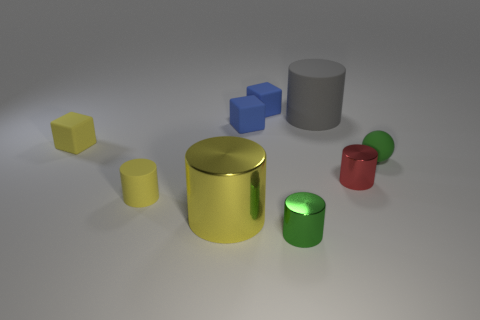Subtract all tiny yellow blocks. How many blocks are left? 2 Subtract all gray cylinders. How many blue cubes are left? 2 Add 1 tiny gray matte objects. How many objects exist? 10 Subtract all gray cylinders. How many cylinders are left? 4 Subtract 3 cylinders. How many cylinders are left? 2 Add 3 blue rubber cubes. How many blue rubber cubes are left? 5 Add 6 yellow shiny things. How many yellow shiny things exist? 7 Subtract 0 green cubes. How many objects are left? 9 Subtract all cylinders. How many objects are left? 4 Subtract all gray cubes. Subtract all cyan cylinders. How many cubes are left? 3 